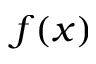Convert formula to latex. <formula><loc_0><loc_0><loc_500><loc_500>f ( x )</formula> 